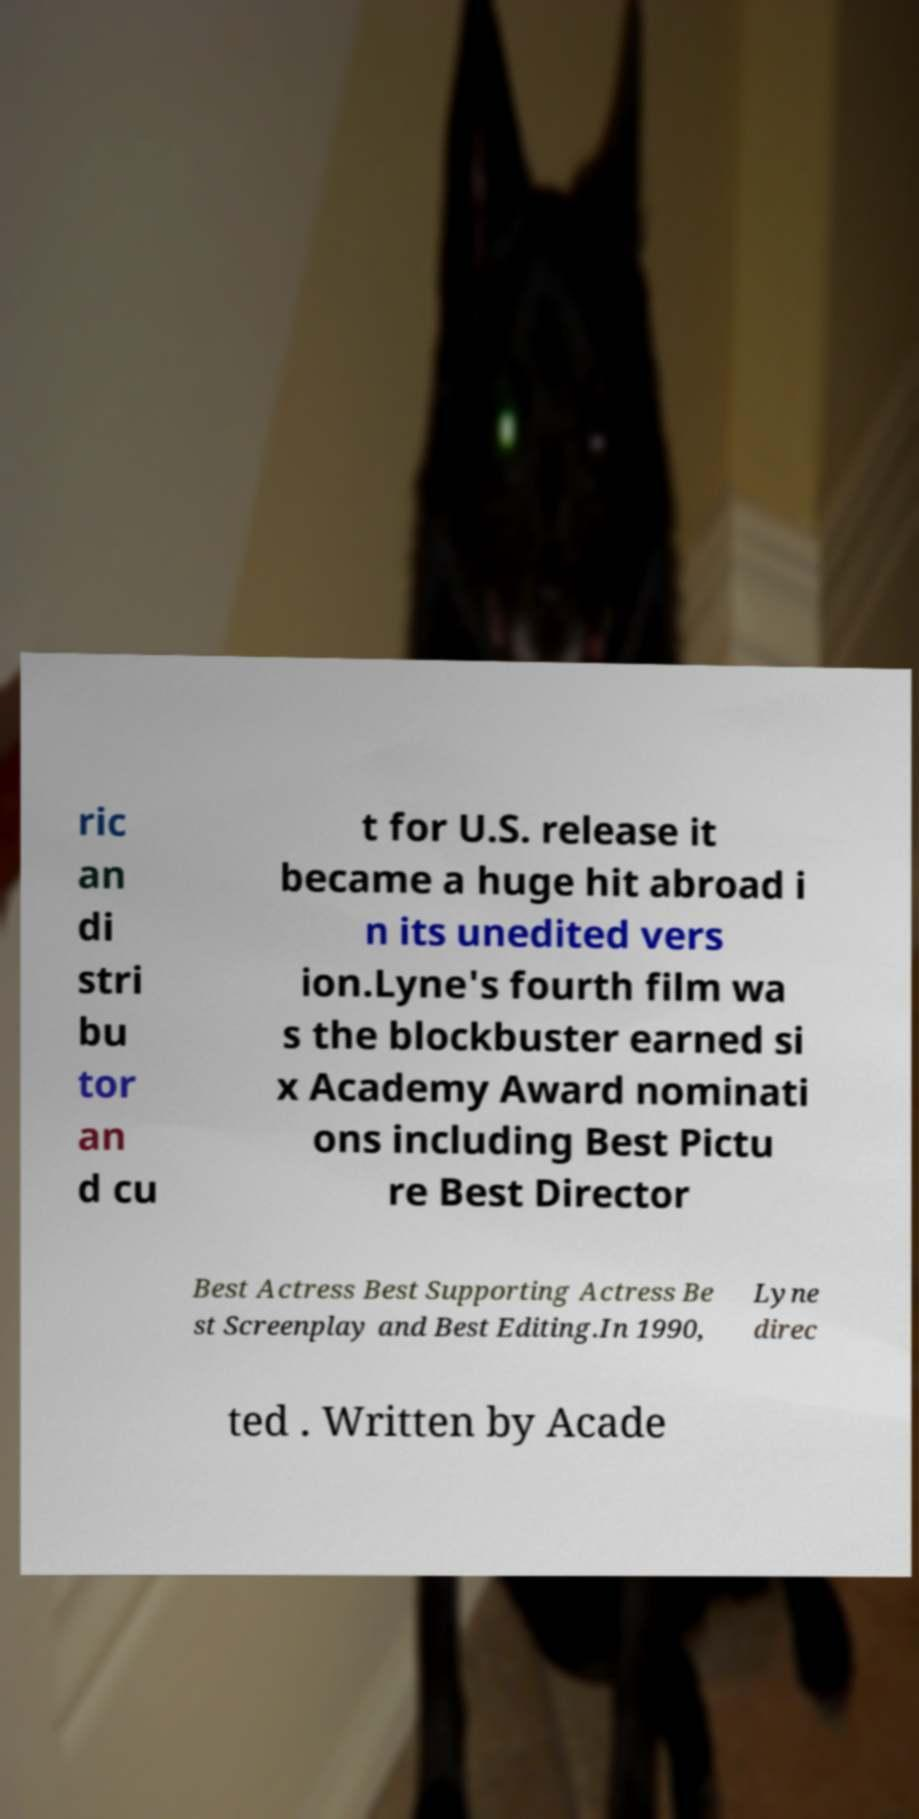There's text embedded in this image that I need extracted. Can you transcribe it verbatim? ric an di stri bu tor an d cu t for U.S. release it became a huge hit abroad i n its unedited vers ion.Lyne's fourth film wa s the blockbuster earned si x Academy Award nominati ons including Best Pictu re Best Director Best Actress Best Supporting Actress Be st Screenplay and Best Editing.In 1990, Lyne direc ted . Written by Acade 